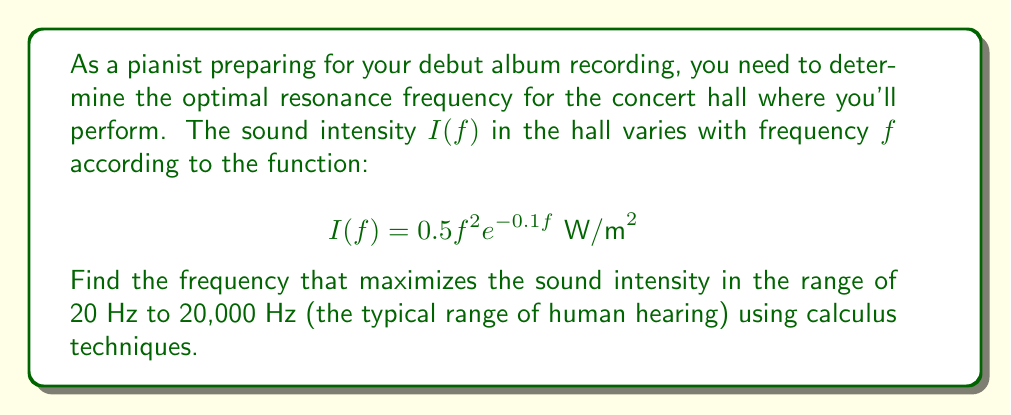Could you help me with this problem? To find the optimal resonance frequency, we need to maximize the sound intensity function $I(f)$ over the given range. We'll use the following steps:

1) First, we need to find the critical points by taking the derivative of $I(f)$ and setting it equal to zero:

   $$I'(f) = (0.5f^2e^{-0.1f})'$$
   $$= 0.5(2fe^{-0.1f} + f^2(-0.1)e^{-0.1f})$$
   $$= 0.5e^{-0.1f}(2f - 0.1f^2)$$

2) Set $I'(f) = 0$ and solve for $f$:

   $$0.5e^{-0.1f}(2f - 0.1f^2) = 0$$
   $$2f - 0.1f^2 = 0$$
   $$f(2 - 0.1f) = 0$$

   This gives us $f = 0$ or $f = 20$

3) $f = 0$ is not in our domain of [20, 20000], but $f = 20$ is.

4) We also need to check the endpoints of our interval:
   - At $f = 20$: $I(20) = 0.5(20^2)e^{-0.1(20)} \approx 67.67$
   - At $f = 20000$: $I(20000) \approx 0$ (due to the exponential decay)

5) Comparing these values, we see that the maximum occurs at $f = 20$ Hz.

6) To confirm this is a maximum and not a minimum, we can check the second derivative:

   $$I''(f) = 0.5e^{-0.1f}(2 - 0.4f - 0.1(2f - 0.1f^2))$$

   At $f = 20$: $I''(20) < 0$, confirming it's a maximum.

Therefore, the optimal resonance frequency for the concert hall is 20 Hz.
Answer: 20 Hz 